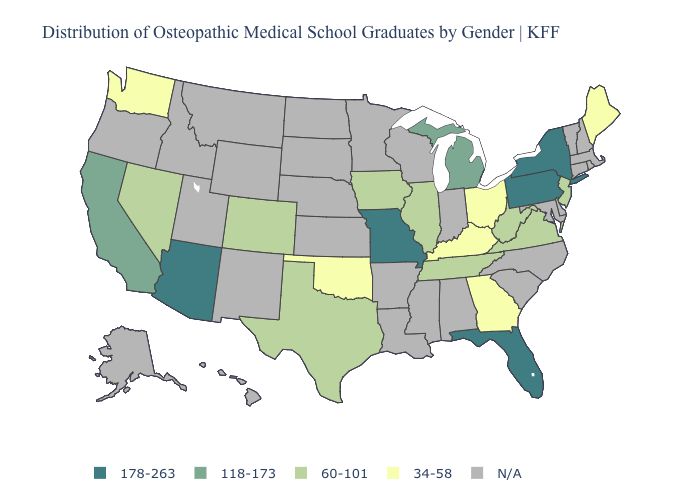Name the states that have a value in the range 178-263?
Write a very short answer. Arizona, Florida, Missouri, New York, Pennsylvania. What is the value of South Dakota?
Give a very brief answer. N/A. Name the states that have a value in the range N/A?
Be succinct. Alabama, Alaska, Arkansas, Connecticut, Delaware, Hawaii, Idaho, Indiana, Kansas, Louisiana, Maryland, Massachusetts, Minnesota, Mississippi, Montana, Nebraska, New Hampshire, New Mexico, North Carolina, North Dakota, Oregon, Rhode Island, South Carolina, South Dakota, Utah, Vermont, Wisconsin, Wyoming. What is the value of Illinois?
Quick response, please. 60-101. How many symbols are there in the legend?
Write a very short answer. 5. What is the lowest value in the USA?
Concise answer only. 34-58. How many symbols are there in the legend?
Write a very short answer. 5. Does the map have missing data?
Write a very short answer. Yes. What is the value of New Jersey?
Concise answer only. 60-101. Is the legend a continuous bar?
Write a very short answer. No. What is the lowest value in the USA?
Answer briefly. 34-58. Does the map have missing data?
Quick response, please. Yes. Name the states that have a value in the range N/A?
Quick response, please. Alabama, Alaska, Arkansas, Connecticut, Delaware, Hawaii, Idaho, Indiana, Kansas, Louisiana, Maryland, Massachusetts, Minnesota, Mississippi, Montana, Nebraska, New Hampshire, New Mexico, North Carolina, North Dakota, Oregon, Rhode Island, South Carolina, South Dakota, Utah, Vermont, Wisconsin, Wyoming. What is the lowest value in the South?
Quick response, please. 34-58. Does the map have missing data?
Concise answer only. Yes. 